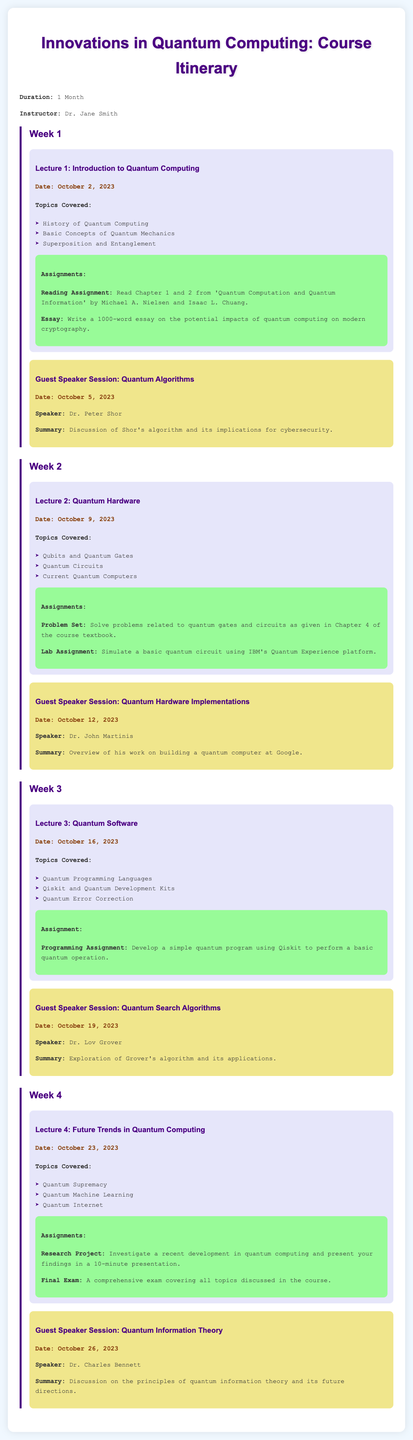What is the duration of the course? The duration is explicitly stated in the document as "1 Month."
Answer: 1 Month Who is the instructor of the course? The instructor's name is provided at the beginning of the document.
Answer: Dr. Jane Smith What is the date of the first lecture? The date for the first lecture is specified in the schedule.
Answer: October 2, 2023 What topics are covered in Lecture 2? The topics listed under Lecture 2 explain the content of that session in detail.
Answer: Qubits and Quantum Gates, Quantum Circuits, Current Quantum Computers Who is the guest speaker on October 19, 2023? The document lists the speaker for each guest session, making this information retrievable.
Answer: Dr. Lov Grover What type of assignment is given after Lecture 3? The document outlines the assignments under each lecture, making this information easy to find.
Answer: Programming Assignment What is the focus of the Research Project in Week 4? The document explicitly states what the research project is about in its assignments section.
Answer: Investigate a recent development in quantum computing Which week features a guest speaker discussing quantum information theory? The weeks are outlined in the document, and each guest session is associated with a specific week.
Answer: Week 4 